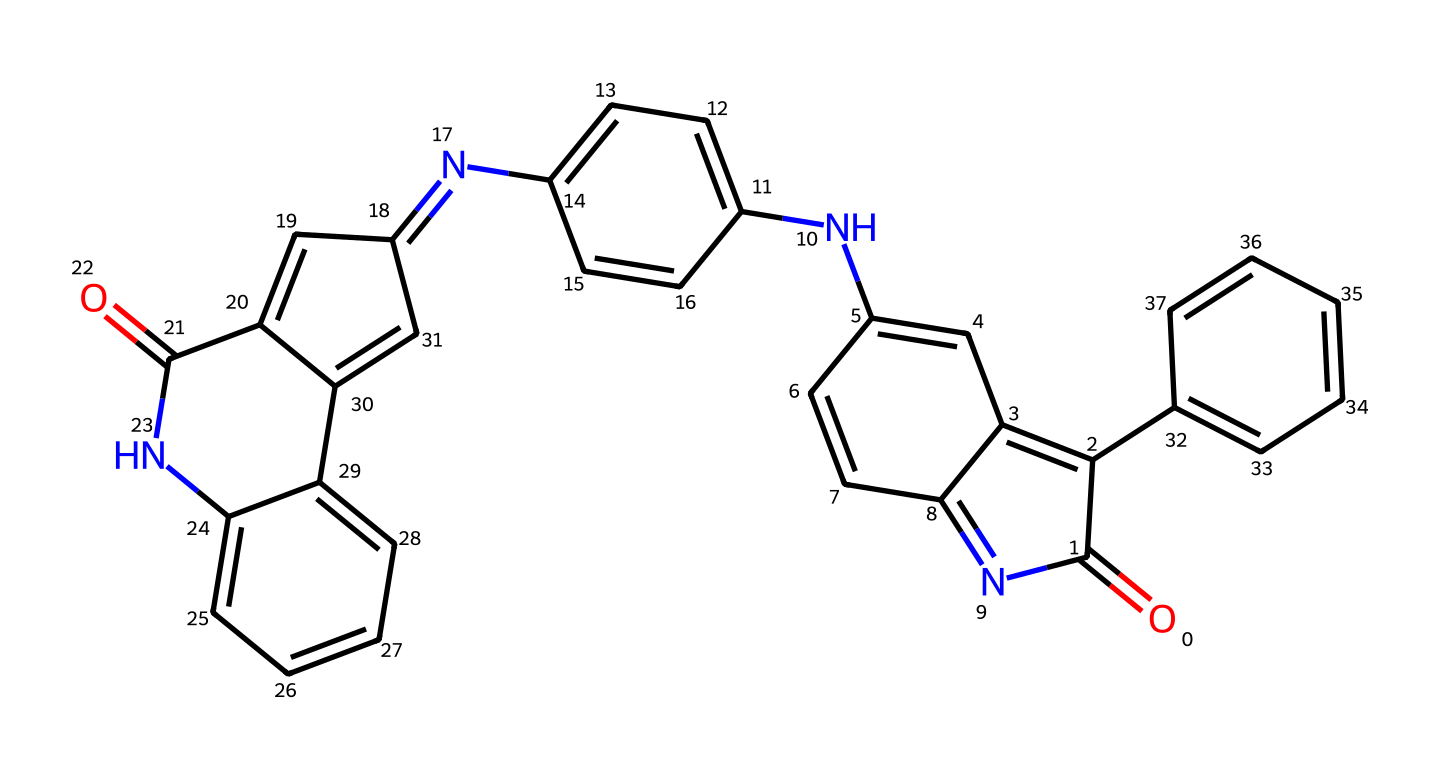What is the primary functional group present in this indigo dye? The chemical structure contains amine (–NH) groups, indicating that it contains nitrogen, which is characteristic of indigo dyes.
Answer: amine How many carbon atoms are in the molecule? By counting each carbon atom in the SMILES representation, we find there are 20 carbon atoms.
Answer: 20 What are the elements present in this molecule? The SMILES representation includes carbon (C), hydrogen (H), nitrogen (N), and oxygen (O), indicating these four elements are present in the molecule.
Answer: carbon, hydrogen, nitrogen, oxygen What structural feature indicates that this molecule may exhibit color? The presence of multiple conjugated double bonds (indicated by alternating single and double bonds) in the chemical structure allows for electron delocalization, which is crucial for color.
Answer: conjugated double bonds How many nitrogen atoms are present in this compound? By examining the SMILES, we can count 4 nitrogen atoms which are indicated in the structure.
Answer: 4 What type of chemical compound is indigo classified as? Indigo is classified as a dye with complex aromatic structures, making it an organic compound with color properties.
Answer: dye 